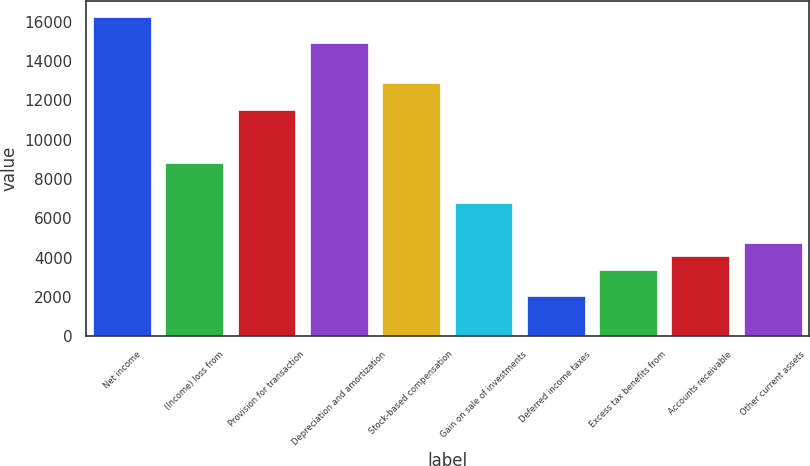Convert chart to OTSL. <chart><loc_0><loc_0><loc_500><loc_500><bar_chart><fcel>Net income<fcel>(Income) loss from<fcel>Provision for transaction<fcel>Depreciation and amortization<fcel>Stock-based compensation<fcel>Gain on sale of investments<fcel>Deferred income taxes<fcel>Excess tax benefits from<fcel>Accounts receivable<fcel>Other current assets<nl><fcel>16261.8<fcel>8812.6<fcel>11521.4<fcel>14907.4<fcel>12875.8<fcel>6781<fcel>2040.6<fcel>3395<fcel>4072.2<fcel>4749.4<nl></chart> 